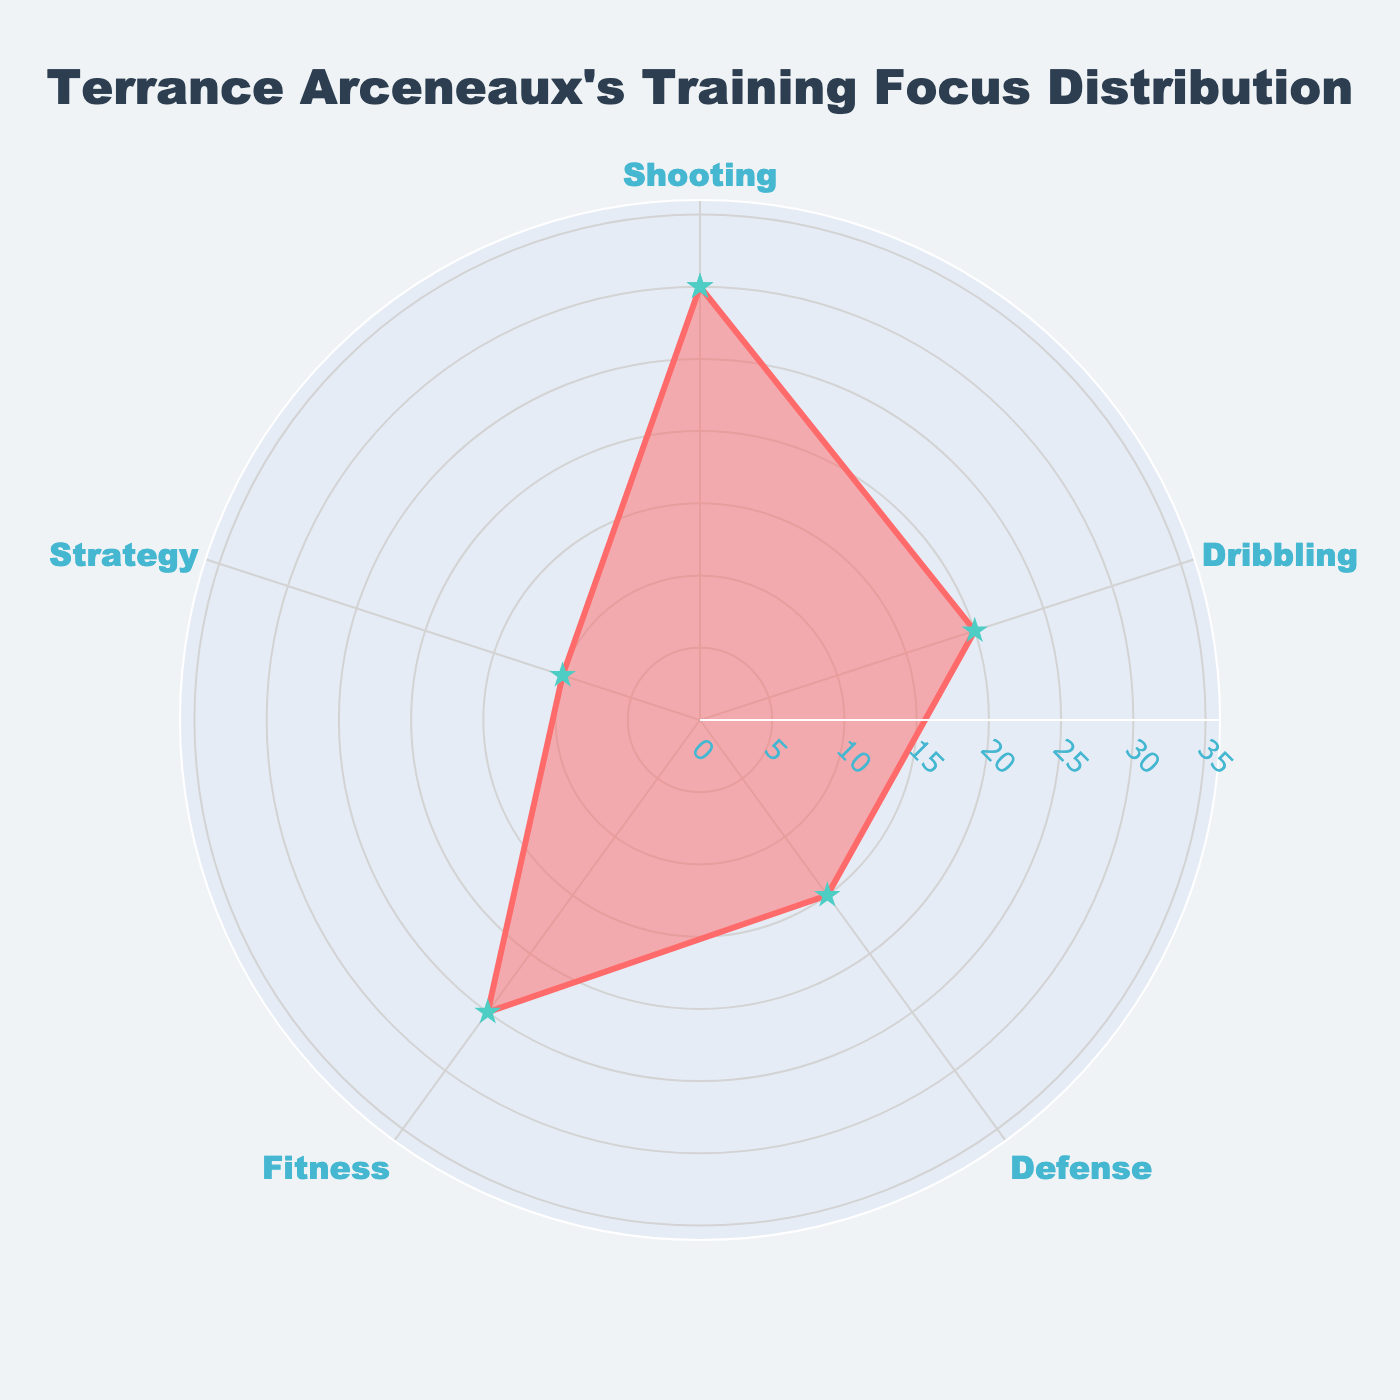What is the title of the chart? The title is the text that appears at the top of the polar chart, usually describing what the chart is about. It helps viewers quickly understand the focus of the chart. The chart's title is "Terrance Arceneaux's Training Focus Distribution".
Answer: Terrance Arceneaux's Training Focus Distribution Which training category has the highest percentage of time spent? To find the answer, look at the radial values extending from the center to the edges of the chart. The category with the longest radial value is Shooting, which is at 30%.
Answer: Shooting How much more time is spent on Fitness compared to Strategy? Find the percentage values for both Fitness and Strategy. Fitness is 25% and Strategy is 10%. The difference is calculated by subtracting 10 from 25.
Answer: 15% What is the average percentage of time spent on all categories? Sum all the percentages: 30% (Shooting) + 20% (Dribbling) + 15% (Defense) + 25% (Fitness) + 10% (Strategy) = 100%. Divide by the number of categories, which is 5. So, the average is 100%/5.
Answer: 20% Is there any category that has a percentage of time spent equal to the average percentage? The average percentage has been calculated as 20%. Looking at the chart, Dribbling is the category with exactly 20% time spent.
Answer: Dribbling Which category has the second-highest time spent? The second-highest percentage is found by comparing the values. Shooting is the highest at 30%, so the next highest is Fitness at 25%.
Answer: Fitness How much time in total is spent on Shooting and Defense? Add the percentages for Shooting and Defense. Shooting is 30% and Defense is 15%. The total time spent is calculated by 30% + 15%.
Answer: 45% Which training category has the lowest percentage of time spent? By looking at the smallest radial value, it is clear that the category with the lowest percentage is Strategy at 10%.
Answer: Strategy What range does the radial axis cover in the chart? The radial axis extends from 0 to 1.2 times the highest value, which is 30%. Therefore, the range is from 0 to 36%.
Answer: 0 to 36% What proportion of the total training time is spent on Dribbling and Fitness combined? The total training time is 100%. Dribbling is 20% and Fitness is 25%, combined they sum to 45%. Therefore, the proportion is 45% out of 100%.
Answer: 45% 